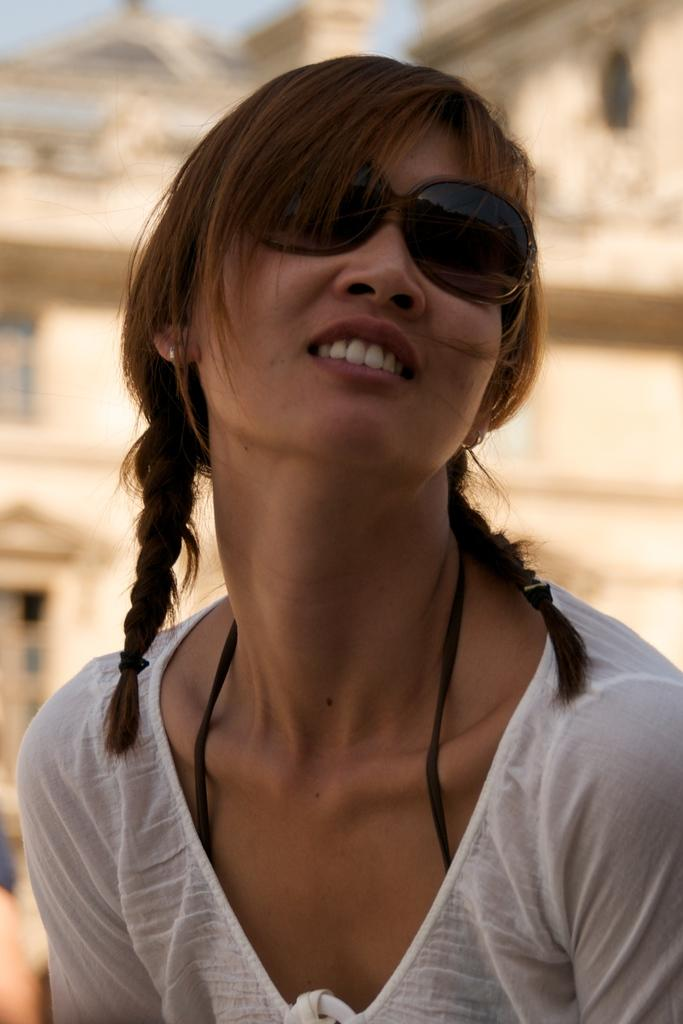Who is the main subject in the image? There is a girl in the image. What is the girl wearing? The girl is wearing a white top. What can be seen in the background of the image? There is a building in the background of the image. What type of wren can be seen perched on the girl's shoulder in the image? There is no wren present in the image; the girl is alone in the image. What message is the girl writing on the building in the image? There is no writing or message visible on the building in the image. 